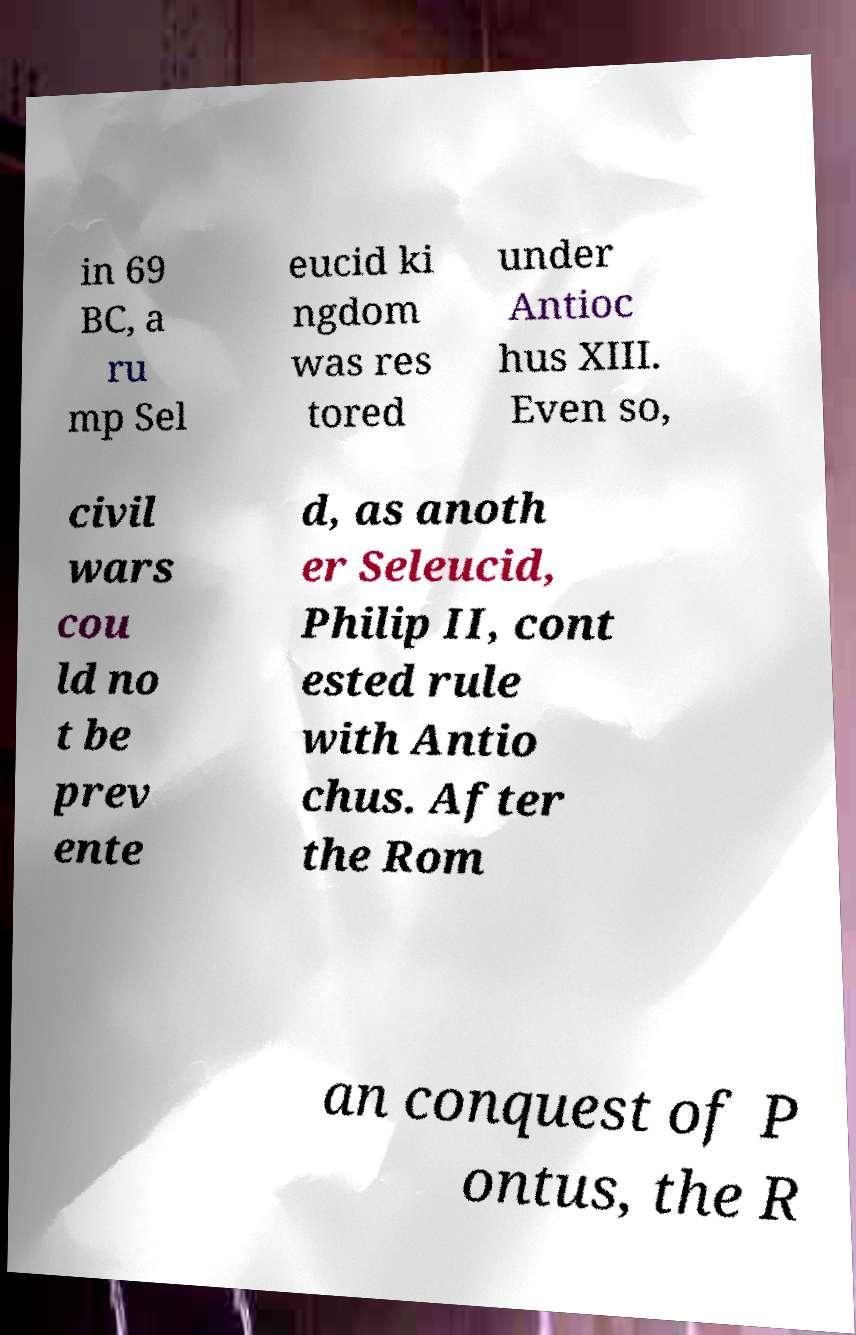Please identify and transcribe the text found in this image. in 69 BC, a ru mp Sel eucid ki ngdom was res tored under Antioc hus XIII. Even so, civil wars cou ld no t be prev ente d, as anoth er Seleucid, Philip II, cont ested rule with Antio chus. After the Rom an conquest of P ontus, the R 